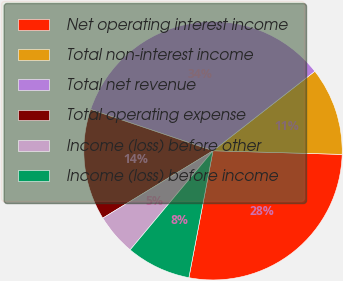Convert chart to OTSL. <chart><loc_0><loc_0><loc_500><loc_500><pie_chart><fcel>Net operating interest income<fcel>Total non-interest income<fcel>Total net revenue<fcel>Total operating expense<fcel>Income (loss) before other<fcel>Income (loss) before income<nl><fcel>27.54%<fcel>11.0%<fcel>34.27%<fcel>13.91%<fcel>5.19%<fcel>8.09%<nl></chart> 